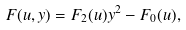<formula> <loc_0><loc_0><loc_500><loc_500>F ( u , y ) = F _ { 2 } ( u ) y ^ { 2 } - F _ { 0 } ( u ) ,</formula> 